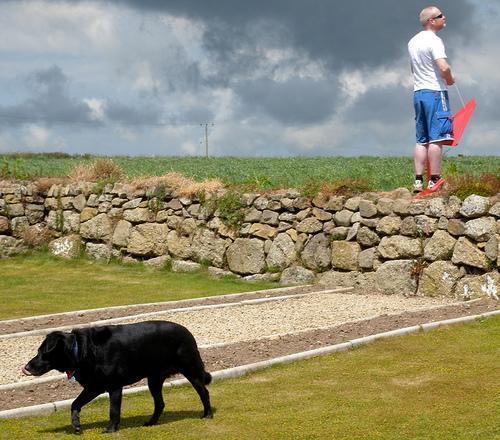How many men are in the picture?
Give a very brief answer. 1. 